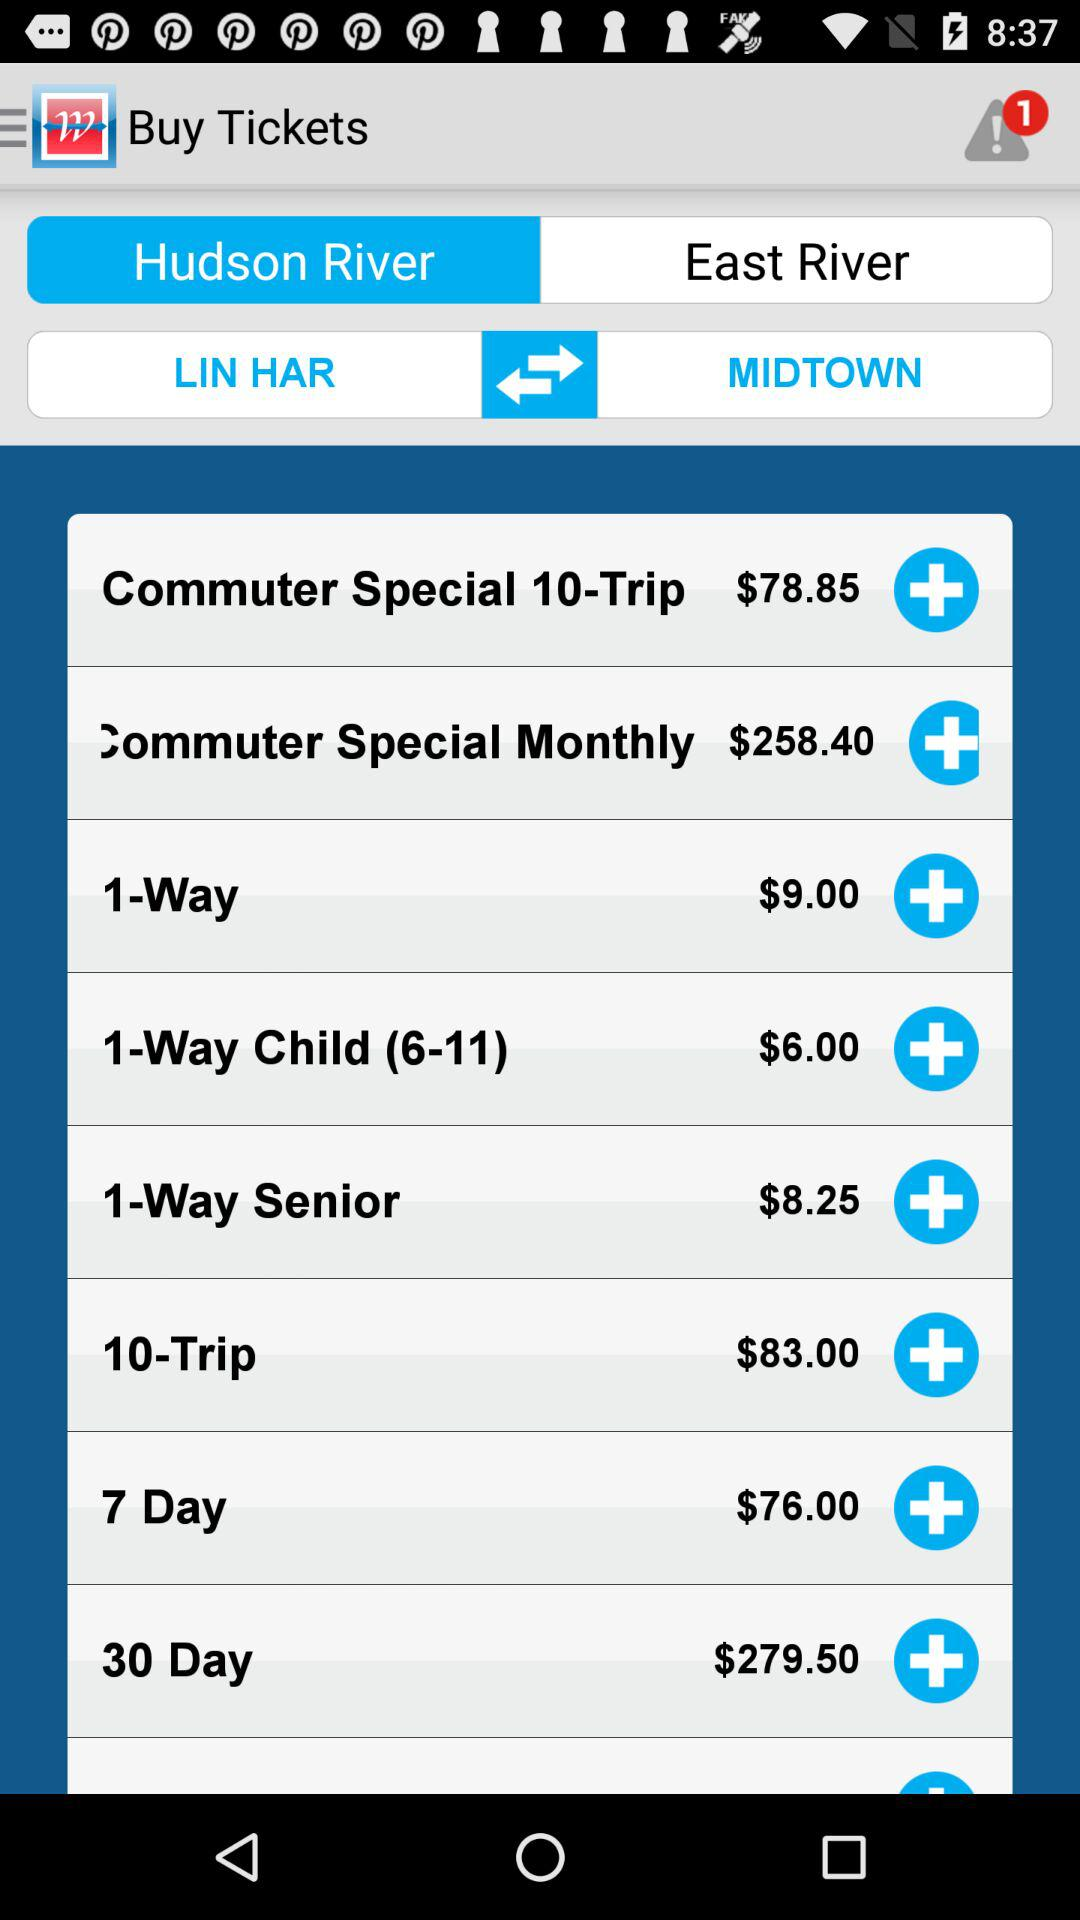What's the price of the 1-way ticket? The price is $9. 